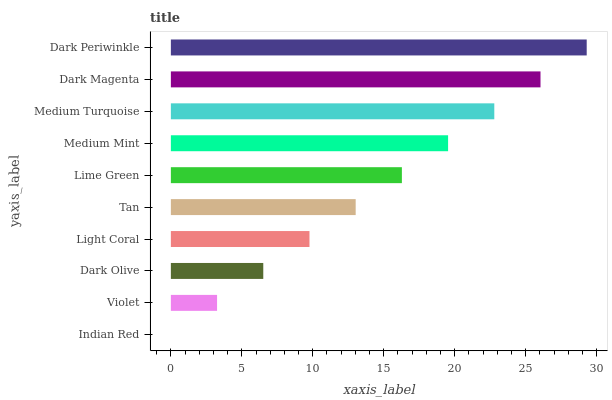Is Indian Red the minimum?
Answer yes or no. Yes. Is Dark Periwinkle the maximum?
Answer yes or no. Yes. Is Violet the minimum?
Answer yes or no. No. Is Violet the maximum?
Answer yes or no. No. Is Violet greater than Indian Red?
Answer yes or no. Yes. Is Indian Red less than Violet?
Answer yes or no. Yes. Is Indian Red greater than Violet?
Answer yes or no. No. Is Violet less than Indian Red?
Answer yes or no. No. Is Lime Green the high median?
Answer yes or no. Yes. Is Tan the low median?
Answer yes or no. Yes. Is Light Coral the high median?
Answer yes or no. No. Is Medium Turquoise the low median?
Answer yes or no. No. 